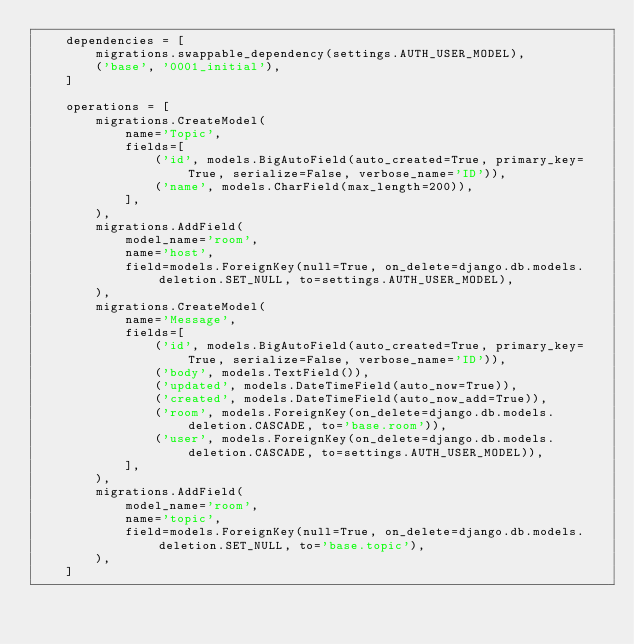Convert code to text. <code><loc_0><loc_0><loc_500><loc_500><_Python_>    dependencies = [
        migrations.swappable_dependency(settings.AUTH_USER_MODEL),
        ('base', '0001_initial'),
    ]

    operations = [
        migrations.CreateModel(
            name='Topic',
            fields=[
                ('id', models.BigAutoField(auto_created=True, primary_key=True, serialize=False, verbose_name='ID')),
                ('name', models.CharField(max_length=200)),
            ],
        ),
        migrations.AddField(
            model_name='room',
            name='host',
            field=models.ForeignKey(null=True, on_delete=django.db.models.deletion.SET_NULL, to=settings.AUTH_USER_MODEL),
        ),
        migrations.CreateModel(
            name='Message',
            fields=[
                ('id', models.BigAutoField(auto_created=True, primary_key=True, serialize=False, verbose_name='ID')),
                ('body', models.TextField()),
                ('updated', models.DateTimeField(auto_now=True)),
                ('created', models.DateTimeField(auto_now_add=True)),
                ('room', models.ForeignKey(on_delete=django.db.models.deletion.CASCADE, to='base.room')),
                ('user', models.ForeignKey(on_delete=django.db.models.deletion.CASCADE, to=settings.AUTH_USER_MODEL)),
            ],
        ),
        migrations.AddField(
            model_name='room',
            name='topic',
            field=models.ForeignKey(null=True, on_delete=django.db.models.deletion.SET_NULL, to='base.topic'),
        ),
    ]
</code> 